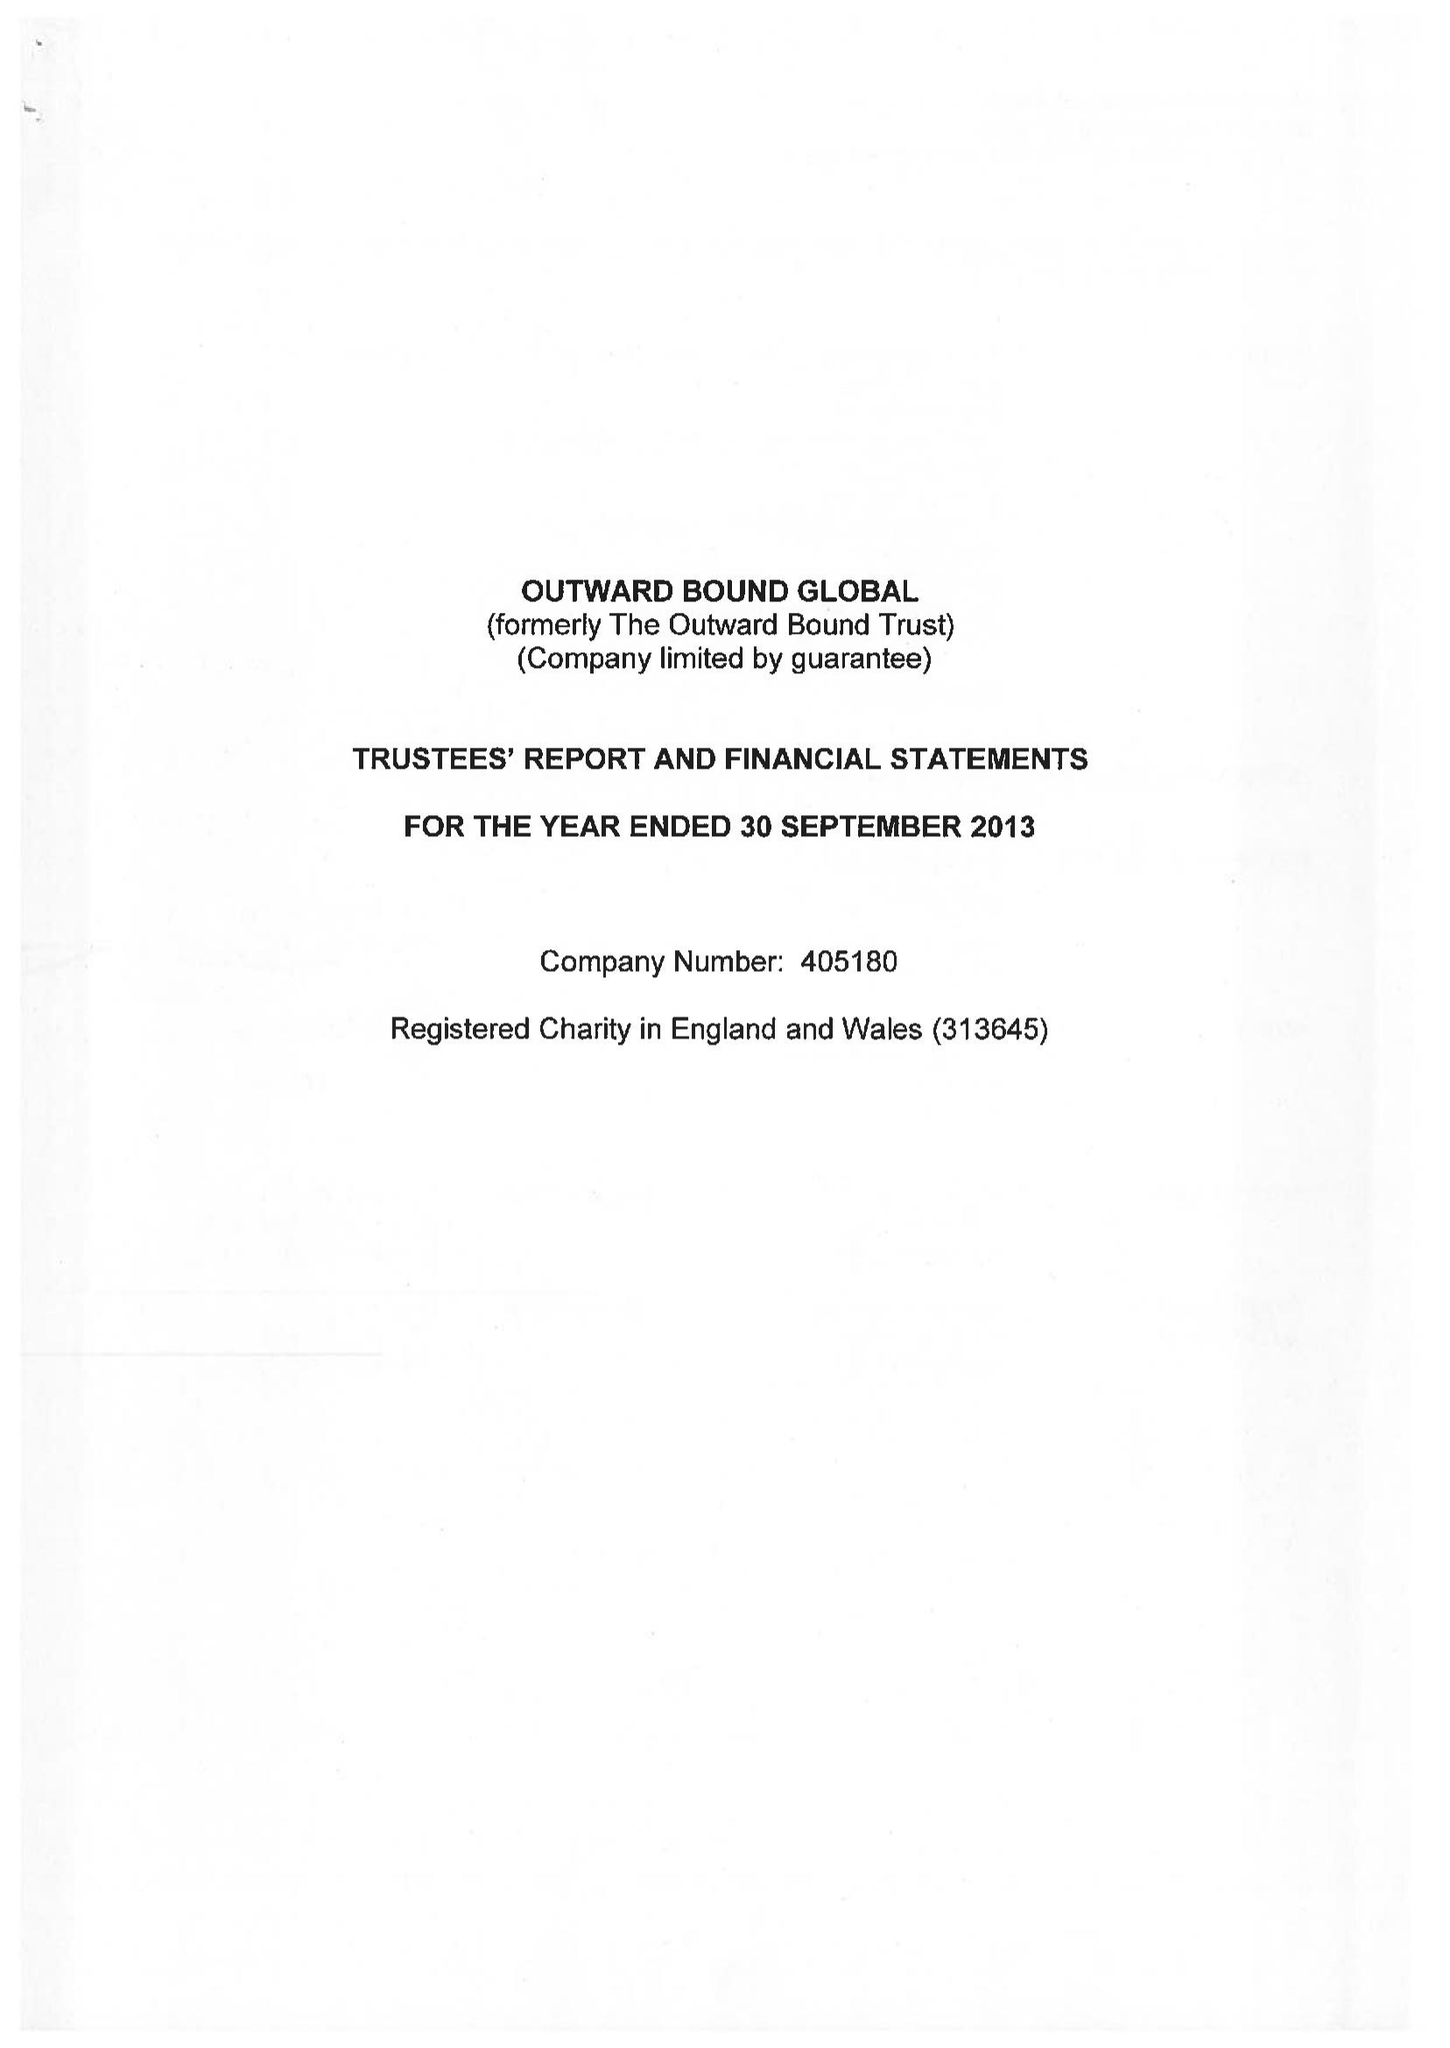What is the value for the charity_name?
Answer the question using a single word or phrase. Outward Bound Global 